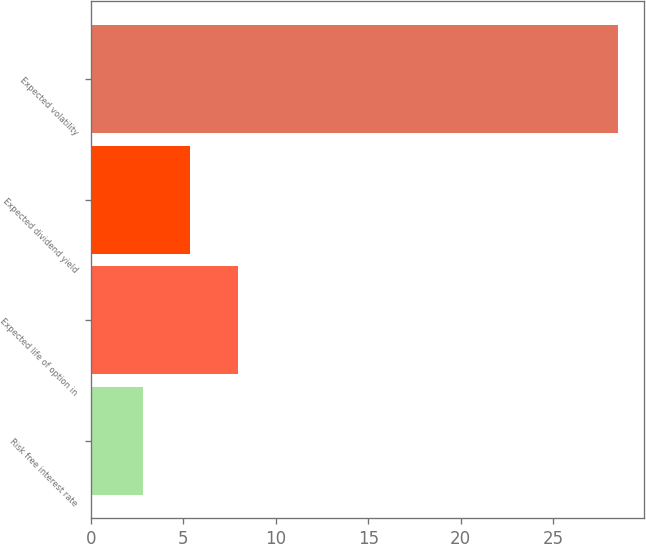Convert chart. <chart><loc_0><loc_0><loc_500><loc_500><bar_chart><fcel>Risk free interest rate<fcel>Expected life of option in<fcel>Expected dividend yield<fcel>Expected volatility<nl><fcel>2.8<fcel>7.94<fcel>5.37<fcel>28.5<nl></chart> 